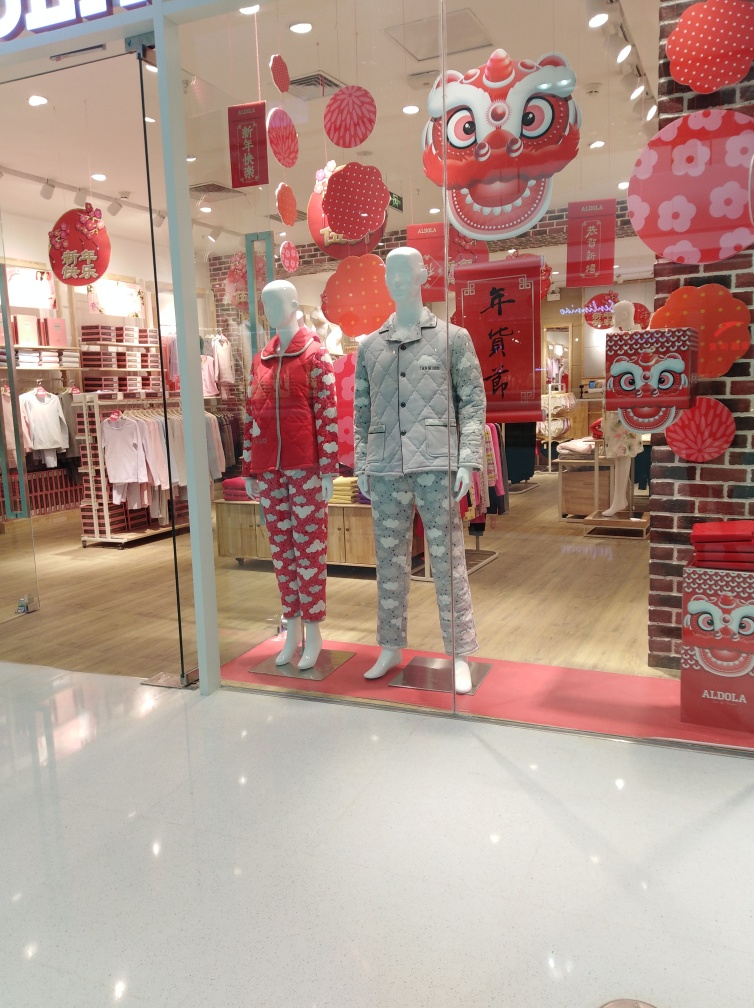What does the text in the decorations mean? While I cannot read specific text from the image, typically, decorations during Chinese New Year feature phrases that wish prosperity, health, and happiness in the coming year. For instance, '恭喜发财 (gong xi fa cai)' means 'Wishing you wealth and prosperity,' a common greeting during the New Year. Is there anything that stands out to you about the way the scene is arranged? The scene is meticulously arranged to create an inviting atmosphere that celebrates a blend of traditional and modern elements. The balance between the mannequins, the strategic placement of the celebratory decorations, and the clear organization of merchandise in the background all work together to draw the attention of passersby and invite them into the store. 